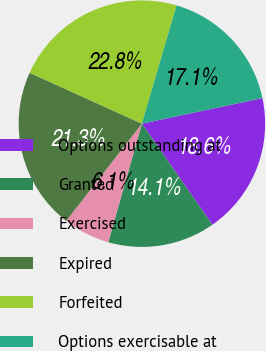Convert chart. <chart><loc_0><loc_0><loc_500><loc_500><pie_chart><fcel>Options outstanding at<fcel>Granted<fcel>Exercised<fcel>Expired<fcel>Forfeited<fcel>Options exercisable at<nl><fcel>18.64%<fcel>14.09%<fcel>6.12%<fcel>21.25%<fcel>22.77%<fcel>17.13%<nl></chart> 